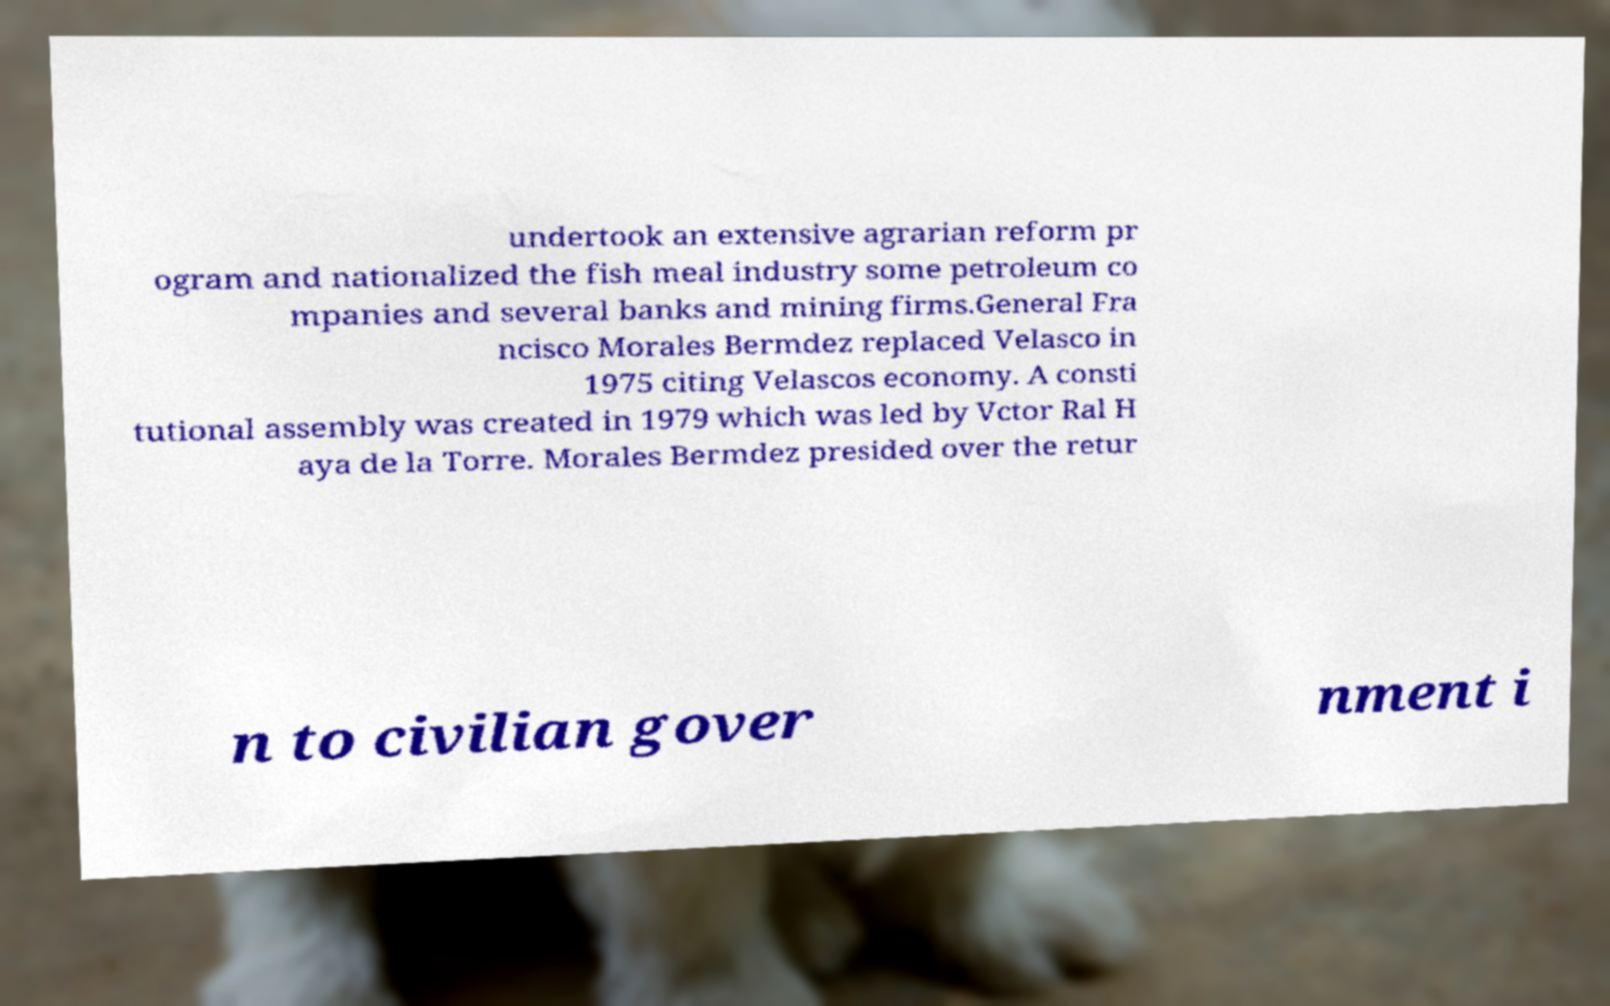There's text embedded in this image that I need extracted. Can you transcribe it verbatim? undertook an extensive agrarian reform pr ogram and nationalized the fish meal industry some petroleum co mpanies and several banks and mining firms.General Fra ncisco Morales Bermdez replaced Velasco in 1975 citing Velascos economy. A consti tutional assembly was created in 1979 which was led by Vctor Ral H aya de la Torre. Morales Bermdez presided over the retur n to civilian gover nment i 